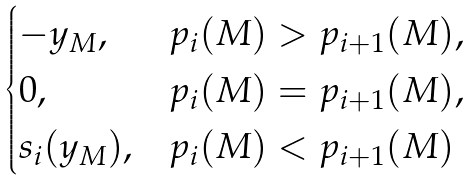<formula> <loc_0><loc_0><loc_500><loc_500>\begin{cases} - y _ { M } , & p _ { i } ( M ) > p _ { i + 1 } ( M ) , \\ 0 , & p _ { i } ( M ) = p _ { i + 1 } ( M ) , \\ s _ { i } ( y _ { M } ) , & p _ { i } ( M ) < p _ { i + 1 } ( M ) \end{cases}</formula> 